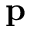Convert formula to latex. <formula><loc_0><loc_0><loc_500><loc_500>p</formula> 